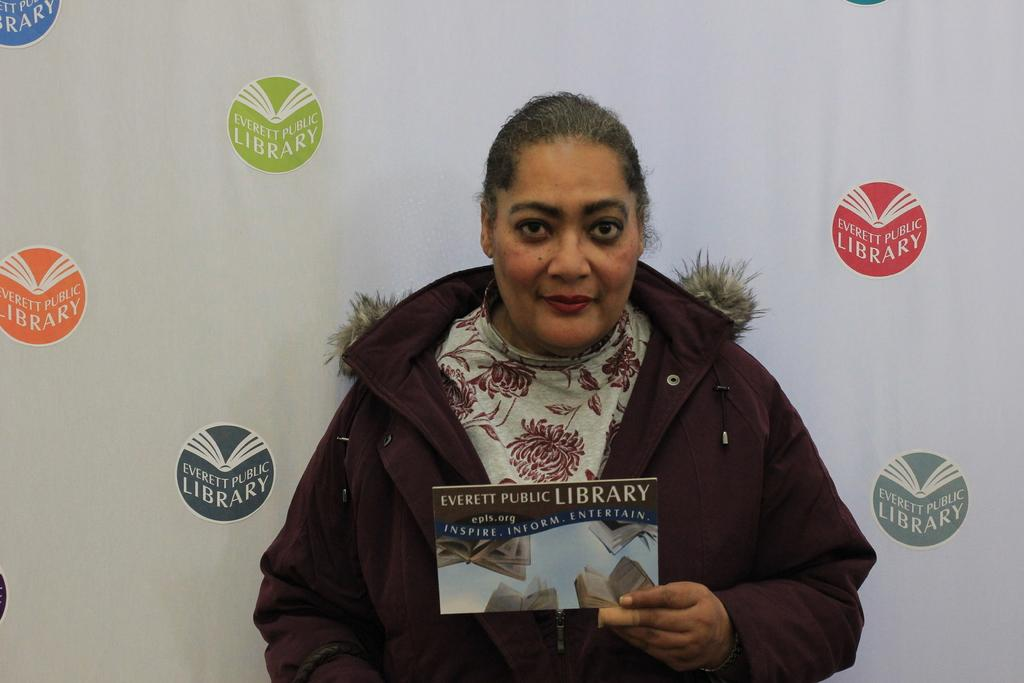Who is the main subject in the picture? There is a woman in the picture. What is the woman wearing? The woman is wearing a brown coat. What is the woman doing in the picture? The woman is standing and showing a paper poster. What can be seen in the background of the image? There is a white color banner in the background. How many children are holding fruit in the image? There are no children or fruit present in the image. 